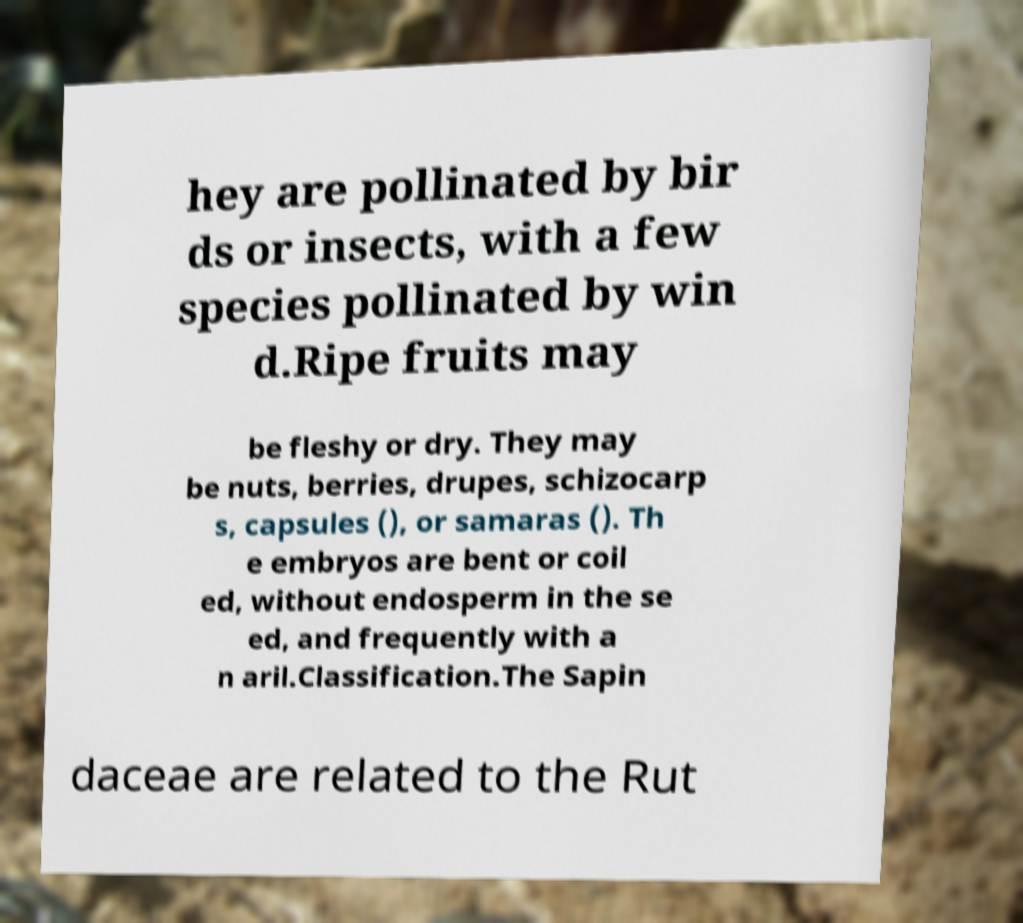Please read and relay the text visible in this image. What does it say? hey are pollinated by bir ds or insects, with a few species pollinated by win d.Ripe fruits may be fleshy or dry. They may be nuts, berries, drupes, schizocarp s, capsules (), or samaras (). Th e embryos are bent or coil ed, without endosperm in the se ed, and frequently with a n aril.Classification.The Sapin daceae are related to the Rut 